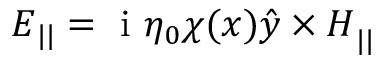<formula> <loc_0><loc_0><loc_500><loc_500>{ E } _ { | | } = i \eta _ { 0 } \chi ( x ) { \hat { y } \times H } _ { | | }</formula> 